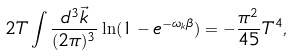<formula> <loc_0><loc_0><loc_500><loc_500>2 T \int \frac { d ^ { 3 } \vec { k } } { ( 2 \pi ) ^ { 3 } } \ln ( 1 - e ^ { - \omega _ { k } \beta } ) = - \frac { \pi ^ { 2 } } { 4 5 } T ^ { 4 } ,</formula> 